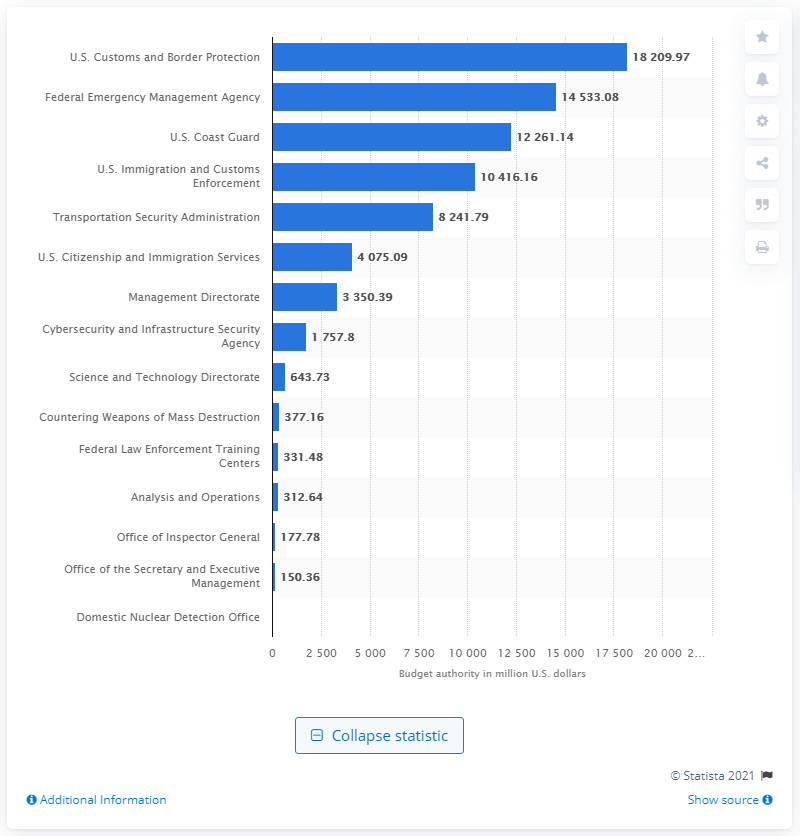List a handful of essential elements in this visual. In Fiscal Year 2021, Customs and Border Protection received a total of $18,209.97. 